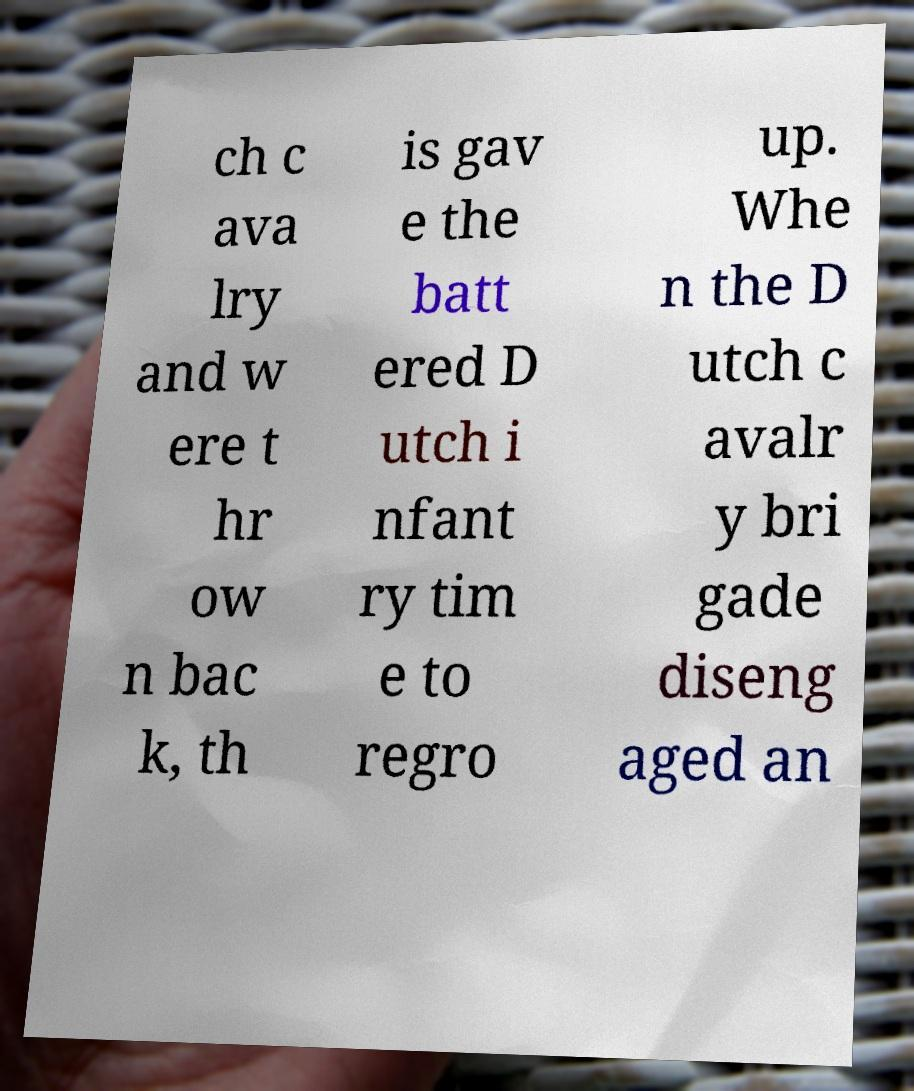Can you accurately transcribe the text from the provided image for me? ch c ava lry and w ere t hr ow n bac k, th is gav e the batt ered D utch i nfant ry tim e to regro up. Whe n the D utch c avalr y bri gade diseng aged an 